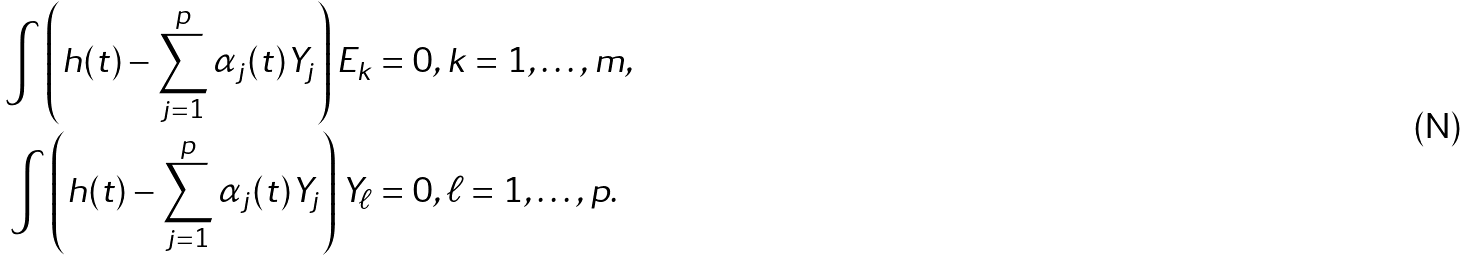<formula> <loc_0><loc_0><loc_500><loc_500>\int \left ( h ( t ) - \sum _ { j = 1 } ^ { p } \alpha _ { j } ( t ) Y _ { j } \right ) E _ { k } & = 0 , k = 1 , \dots , m , \\ \int \left ( h ( t ) - \sum _ { j = 1 } ^ { p } \alpha _ { j } ( t ) Y _ { j } \right ) Y _ { \ell } & = 0 , \ell = 1 , \dots , p .</formula> 